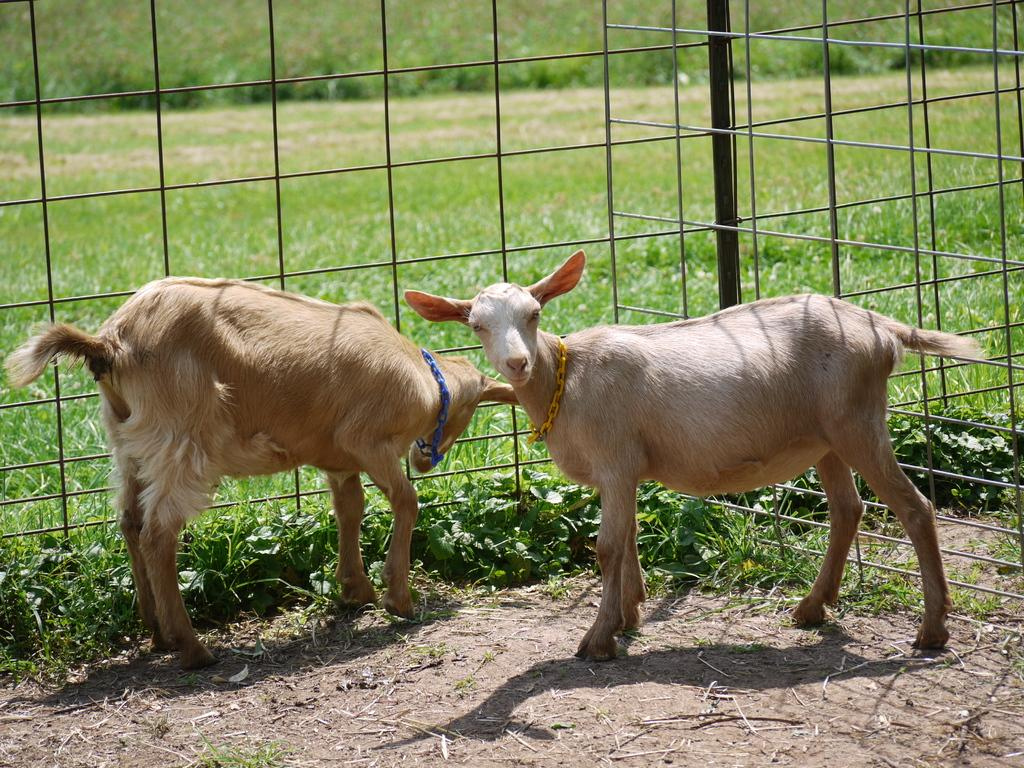How many animals can be seen in the image? There are two animals in the image. What colors are the animals? The animals are brown and white in color. What type of vegetation is visible in the image? There is green grass visible in the image. What kind of structure can be seen in the image? There is a railing in the image. What type of shoe is the animal wearing in the image? There are no shoes present in the image, as the animals are not wearing any clothing or accessories. 